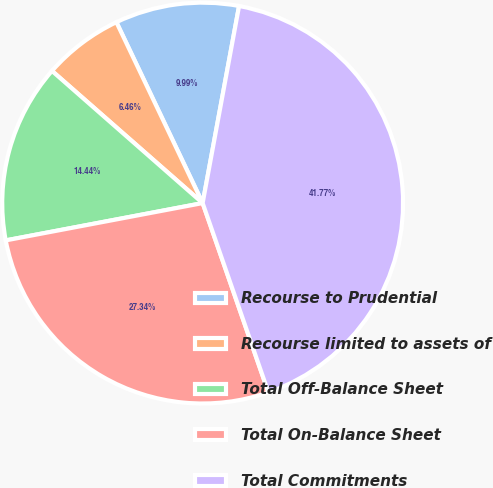Convert chart to OTSL. <chart><loc_0><loc_0><loc_500><loc_500><pie_chart><fcel>Recourse to Prudential<fcel>Recourse limited to assets of<fcel>Total Off-Balance Sheet<fcel>Total On-Balance Sheet<fcel>Total Commitments<nl><fcel>9.99%<fcel>6.46%<fcel>14.44%<fcel>27.34%<fcel>41.77%<nl></chart> 